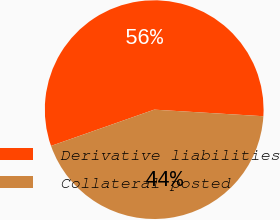<chart> <loc_0><loc_0><loc_500><loc_500><pie_chart><fcel>Derivative liabilities<fcel>Collateral posted<nl><fcel>56.34%<fcel>43.66%<nl></chart> 